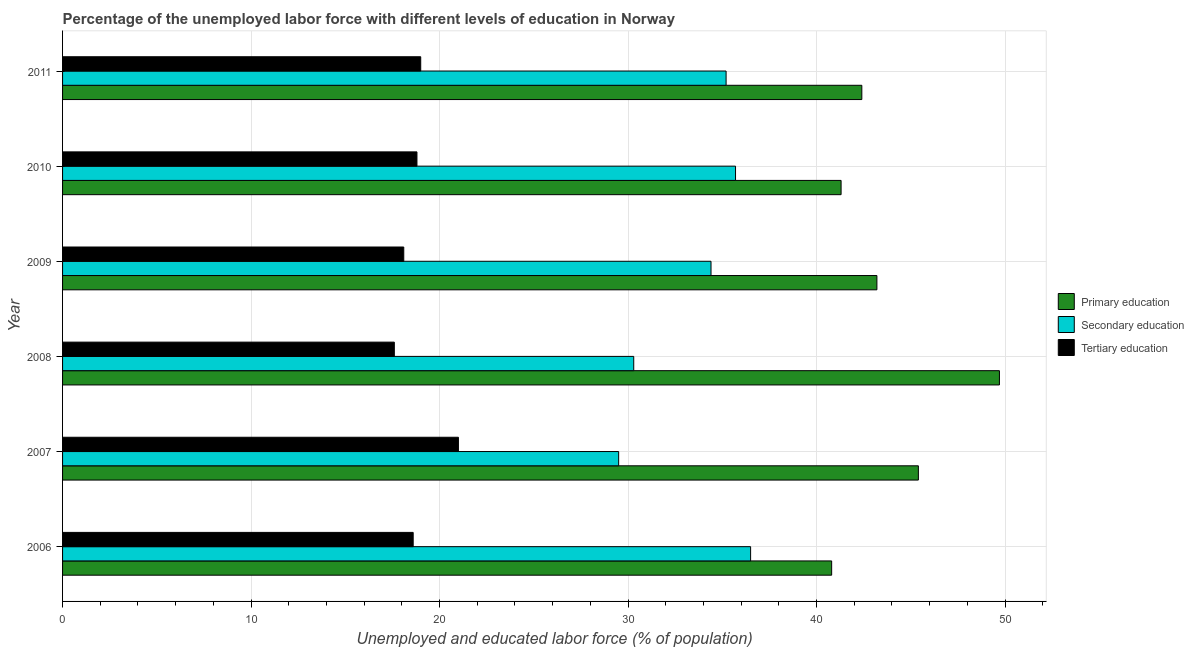How many different coloured bars are there?
Your response must be concise. 3. How many groups of bars are there?
Offer a terse response. 6. How many bars are there on the 6th tick from the top?
Provide a short and direct response. 3. What is the label of the 5th group of bars from the top?
Offer a very short reply. 2007. What is the percentage of labor force who received tertiary education in 2007?
Provide a short and direct response. 21. Across all years, what is the minimum percentage of labor force who received primary education?
Your answer should be very brief. 40.8. In which year was the percentage of labor force who received primary education maximum?
Keep it short and to the point. 2008. In which year was the percentage of labor force who received tertiary education minimum?
Provide a short and direct response. 2008. What is the total percentage of labor force who received tertiary education in the graph?
Your answer should be very brief. 113.1. What is the difference between the percentage of labor force who received tertiary education in 2006 and that in 2011?
Offer a very short reply. -0.4. What is the difference between the percentage of labor force who received primary education in 2006 and the percentage of labor force who received secondary education in 2010?
Offer a very short reply. 5.1. What is the average percentage of labor force who received primary education per year?
Give a very brief answer. 43.8. In how many years, is the percentage of labor force who received tertiary education greater than 46 %?
Your response must be concise. 0. What is the ratio of the percentage of labor force who received tertiary education in 2006 to that in 2008?
Your answer should be very brief. 1.06. Is the difference between the percentage of labor force who received secondary education in 2006 and 2007 greater than the difference between the percentage of labor force who received tertiary education in 2006 and 2007?
Provide a short and direct response. Yes. What is the difference between the highest and the second highest percentage of labor force who received primary education?
Offer a terse response. 4.3. What is the difference between the highest and the lowest percentage of labor force who received secondary education?
Provide a short and direct response. 7. In how many years, is the percentage of labor force who received secondary education greater than the average percentage of labor force who received secondary education taken over all years?
Offer a terse response. 4. What does the 2nd bar from the bottom in 2006 represents?
Keep it short and to the point. Secondary education. How many bars are there?
Your response must be concise. 18. Are all the bars in the graph horizontal?
Provide a short and direct response. Yes. How many years are there in the graph?
Provide a succinct answer. 6. Does the graph contain grids?
Your response must be concise. Yes. How many legend labels are there?
Provide a short and direct response. 3. How are the legend labels stacked?
Keep it short and to the point. Vertical. What is the title of the graph?
Ensure brevity in your answer.  Percentage of the unemployed labor force with different levels of education in Norway. Does "Poland" appear as one of the legend labels in the graph?
Your answer should be very brief. No. What is the label or title of the X-axis?
Provide a short and direct response. Unemployed and educated labor force (% of population). What is the label or title of the Y-axis?
Provide a succinct answer. Year. What is the Unemployed and educated labor force (% of population) of Primary education in 2006?
Offer a terse response. 40.8. What is the Unemployed and educated labor force (% of population) of Secondary education in 2006?
Your answer should be very brief. 36.5. What is the Unemployed and educated labor force (% of population) in Tertiary education in 2006?
Your response must be concise. 18.6. What is the Unemployed and educated labor force (% of population) in Primary education in 2007?
Keep it short and to the point. 45.4. What is the Unemployed and educated labor force (% of population) of Secondary education in 2007?
Make the answer very short. 29.5. What is the Unemployed and educated labor force (% of population) in Tertiary education in 2007?
Ensure brevity in your answer.  21. What is the Unemployed and educated labor force (% of population) of Primary education in 2008?
Provide a succinct answer. 49.7. What is the Unemployed and educated labor force (% of population) in Secondary education in 2008?
Your response must be concise. 30.3. What is the Unemployed and educated labor force (% of population) in Tertiary education in 2008?
Offer a very short reply. 17.6. What is the Unemployed and educated labor force (% of population) in Primary education in 2009?
Your answer should be very brief. 43.2. What is the Unemployed and educated labor force (% of population) in Secondary education in 2009?
Your answer should be compact. 34.4. What is the Unemployed and educated labor force (% of population) of Tertiary education in 2009?
Provide a short and direct response. 18.1. What is the Unemployed and educated labor force (% of population) in Primary education in 2010?
Offer a very short reply. 41.3. What is the Unemployed and educated labor force (% of population) of Secondary education in 2010?
Provide a short and direct response. 35.7. What is the Unemployed and educated labor force (% of population) in Tertiary education in 2010?
Offer a very short reply. 18.8. What is the Unemployed and educated labor force (% of population) of Primary education in 2011?
Keep it short and to the point. 42.4. What is the Unemployed and educated labor force (% of population) in Secondary education in 2011?
Provide a short and direct response. 35.2. Across all years, what is the maximum Unemployed and educated labor force (% of population) of Primary education?
Your answer should be compact. 49.7. Across all years, what is the maximum Unemployed and educated labor force (% of population) in Secondary education?
Your answer should be very brief. 36.5. Across all years, what is the maximum Unemployed and educated labor force (% of population) in Tertiary education?
Your answer should be compact. 21. Across all years, what is the minimum Unemployed and educated labor force (% of population) of Primary education?
Give a very brief answer. 40.8. Across all years, what is the minimum Unemployed and educated labor force (% of population) in Secondary education?
Make the answer very short. 29.5. Across all years, what is the minimum Unemployed and educated labor force (% of population) of Tertiary education?
Offer a terse response. 17.6. What is the total Unemployed and educated labor force (% of population) in Primary education in the graph?
Your response must be concise. 262.8. What is the total Unemployed and educated labor force (% of population) of Secondary education in the graph?
Offer a very short reply. 201.6. What is the total Unemployed and educated labor force (% of population) in Tertiary education in the graph?
Your response must be concise. 113.1. What is the difference between the Unemployed and educated labor force (% of population) in Tertiary education in 2006 and that in 2007?
Provide a succinct answer. -2.4. What is the difference between the Unemployed and educated labor force (% of population) in Primary education in 2006 and that in 2008?
Keep it short and to the point. -8.9. What is the difference between the Unemployed and educated labor force (% of population) in Secondary education in 2006 and that in 2008?
Ensure brevity in your answer.  6.2. What is the difference between the Unemployed and educated labor force (% of population) of Tertiary education in 2006 and that in 2008?
Keep it short and to the point. 1. What is the difference between the Unemployed and educated labor force (% of population) in Secondary education in 2006 and that in 2009?
Your response must be concise. 2.1. What is the difference between the Unemployed and educated labor force (% of population) in Tertiary education in 2006 and that in 2009?
Ensure brevity in your answer.  0.5. What is the difference between the Unemployed and educated labor force (% of population) in Primary education in 2006 and that in 2010?
Your answer should be compact. -0.5. What is the difference between the Unemployed and educated labor force (% of population) in Secondary education in 2006 and that in 2010?
Your answer should be very brief. 0.8. What is the difference between the Unemployed and educated labor force (% of population) of Tertiary education in 2006 and that in 2010?
Your answer should be compact. -0.2. What is the difference between the Unemployed and educated labor force (% of population) of Secondary education in 2006 and that in 2011?
Keep it short and to the point. 1.3. What is the difference between the Unemployed and educated labor force (% of population) in Primary education in 2007 and that in 2008?
Provide a short and direct response. -4.3. What is the difference between the Unemployed and educated labor force (% of population) of Secondary education in 2007 and that in 2008?
Offer a very short reply. -0.8. What is the difference between the Unemployed and educated labor force (% of population) of Tertiary education in 2007 and that in 2008?
Provide a succinct answer. 3.4. What is the difference between the Unemployed and educated labor force (% of population) of Primary education in 2007 and that in 2009?
Your answer should be compact. 2.2. What is the difference between the Unemployed and educated labor force (% of population) of Primary education in 2007 and that in 2010?
Give a very brief answer. 4.1. What is the difference between the Unemployed and educated labor force (% of population) in Tertiary education in 2007 and that in 2010?
Provide a succinct answer. 2.2. What is the difference between the Unemployed and educated labor force (% of population) of Primary education in 2007 and that in 2011?
Keep it short and to the point. 3. What is the difference between the Unemployed and educated labor force (% of population) in Secondary education in 2007 and that in 2011?
Your answer should be compact. -5.7. What is the difference between the Unemployed and educated labor force (% of population) of Primary education in 2008 and that in 2009?
Your answer should be compact. 6.5. What is the difference between the Unemployed and educated labor force (% of population) in Tertiary education in 2008 and that in 2009?
Keep it short and to the point. -0.5. What is the difference between the Unemployed and educated labor force (% of population) in Secondary education in 2008 and that in 2010?
Ensure brevity in your answer.  -5.4. What is the difference between the Unemployed and educated labor force (% of population) in Primary education in 2008 and that in 2011?
Your response must be concise. 7.3. What is the difference between the Unemployed and educated labor force (% of population) of Tertiary education in 2008 and that in 2011?
Keep it short and to the point. -1.4. What is the difference between the Unemployed and educated labor force (% of population) in Secondary education in 2009 and that in 2010?
Your answer should be very brief. -1.3. What is the difference between the Unemployed and educated labor force (% of population) in Tertiary education in 2009 and that in 2010?
Ensure brevity in your answer.  -0.7. What is the difference between the Unemployed and educated labor force (% of population) of Primary education in 2009 and that in 2011?
Make the answer very short. 0.8. What is the difference between the Unemployed and educated labor force (% of population) of Primary education in 2010 and that in 2011?
Ensure brevity in your answer.  -1.1. What is the difference between the Unemployed and educated labor force (% of population) in Primary education in 2006 and the Unemployed and educated labor force (% of population) in Secondary education in 2007?
Your answer should be compact. 11.3. What is the difference between the Unemployed and educated labor force (% of population) in Primary education in 2006 and the Unemployed and educated labor force (% of population) in Tertiary education in 2007?
Offer a terse response. 19.8. What is the difference between the Unemployed and educated labor force (% of population) in Secondary education in 2006 and the Unemployed and educated labor force (% of population) in Tertiary education in 2007?
Offer a terse response. 15.5. What is the difference between the Unemployed and educated labor force (% of population) of Primary education in 2006 and the Unemployed and educated labor force (% of population) of Tertiary education in 2008?
Offer a terse response. 23.2. What is the difference between the Unemployed and educated labor force (% of population) of Secondary education in 2006 and the Unemployed and educated labor force (% of population) of Tertiary education in 2008?
Provide a succinct answer. 18.9. What is the difference between the Unemployed and educated labor force (% of population) of Primary education in 2006 and the Unemployed and educated labor force (% of population) of Secondary education in 2009?
Offer a very short reply. 6.4. What is the difference between the Unemployed and educated labor force (% of population) of Primary education in 2006 and the Unemployed and educated labor force (% of population) of Tertiary education in 2009?
Keep it short and to the point. 22.7. What is the difference between the Unemployed and educated labor force (% of population) in Primary education in 2006 and the Unemployed and educated labor force (% of population) in Secondary education in 2010?
Ensure brevity in your answer.  5.1. What is the difference between the Unemployed and educated labor force (% of population) of Primary education in 2006 and the Unemployed and educated labor force (% of population) of Secondary education in 2011?
Provide a succinct answer. 5.6. What is the difference between the Unemployed and educated labor force (% of population) of Primary education in 2006 and the Unemployed and educated labor force (% of population) of Tertiary education in 2011?
Keep it short and to the point. 21.8. What is the difference between the Unemployed and educated labor force (% of population) in Primary education in 2007 and the Unemployed and educated labor force (% of population) in Secondary education in 2008?
Offer a very short reply. 15.1. What is the difference between the Unemployed and educated labor force (% of population) in Primary education in 2007 and the Unemployed and educated labor force (% of population) in Tertiary education in 2008?
Your answer should be very brief. 27.8. What is the difference between the Unemployed and educated labor force (% of population) of Primary education in 2007 and the Unemployed and educated labor force (% of population) of Secondary education in 2009?
Provide a short and direct response. 11. What is the difference between the Unemployed and educated labor force (% of population) of Primary education in 2007 and the Unemployed and educated labor force (% of population) of Tertiary education in 2009?
Your answer should be compact. 27.3. What is the difference between the Unemployed and educated labor force (% of population) in Primary education in 2007 and the Unemployed and educated labor force (% of population) in Tertiary education in 2010?
Make the answer very short. 26.6. What is the difference between the Unemployed and educated labor force (% of population) in Primary education in 2007 and the Unemployed and educated labor force (% of population) in Tertiary education in 2011?
Provide a succinct answer. 26.4. What is the difference between the Unemployed and educated labor force (% of population) of Secondary education in 2007 and the Unemployed and educated labor force (% of population) of Tertiary education in 2011?
Your answer should be very brief. 10.5. What is the difference between the Unemployed and educated labor force (% of population) in Primary education in 2008 and the Unemployed and educated labor force (% of population) in Secondary education in 2009?
Ensure brevity in your answer.  15.3. What is the difference between the Unemployed and educated labor force (% of population) in Primary education in 2008 and the Unemployed and educated labor force (% of population) in Tertiary education in 2009?
Provide a succinct answer. 31.6. What is the difference between the Unemployed and educated labor force (% of population) of Secondary education in 2008 and the Unemployed and educated labor force (% of population) of Tertiary education in 2009?
Make the answer very short. 12.2. What is the difference between the Unemployed and educated labor force (% of population) of Primary education in 2008 and the Unemployed and educated labor force (% of population) of Tertiary education in 2010?
Keep it short and to the point. 30.9. What is the difference between the Unemployed and educated labor force (% of population) of Primary education in 2008 and the Unemployed and educated labor force (% of population) of Secondary education in 2011?
Your response must be concise. 14.5. What is the difference between the Unemployed and educated labor force (% of population) of Primary education in 2008 and the Unemployed and educated labor force (% of population) of Tertiary education in 2011?
Your answer should be compact. 30.7. What is the difference between the Unemployed and educated labor force (% of population) of Secondary education in 2008 and the Unemployed and educated labor force (% of population) of Tertiary education in 2011?
Offer a very short reply. 11.3. What is the difference between the Unemployed and educated labor force (% of population) of Primary education in 2009 and the Unemployed and educated labor force (% of population) of Secondary education in 2010?
Your response must be concise. 7.5. What is the difference between the Unemployed and educated labor force (% of population) in Primary education in 2009 and the Unemployed and educated labor force (% of population) in Tertiary education in 2010?
Make the answer very short. 24.4. What is the difference between the Unemployed and educated labor force (% of population) in Secondary education in 2009 and the Unemployed and educated labor force (% of population) in Tertiary education in 2010?
Your answer should be compact. 15.6. What is the difference between the Unemployed and educated labor force (% of population) of Primary education in 2009 and the Unemployed and educated labor force (% of population) of Secondary education in 2011?
Provide a succinct answer. 8. What is the difference between the Unemployed and educated labor force (% of population) in Primary education in 2009 and the Unemployed and educated labor force (% of population) in Tertiary education in 2011?
Make the answer very short. 24.2. What is the difference between the Unemployed and educated labor force (% of population) of Primary education in 2010 and the Unemployed and educated labor force (% of population) of Secondary education in 2011?
Provide a succinct answer. 6.1. What is the difference between the Unemployed and educated labor force (% of population) of Primary education in 2010 and the Unemployed and educated labor force (% of population) of Tertiary education in 2011?
Provide a succinct answer. 22.3. What is the average Unemployed and educated labor force (% of population) of Primary education per year?
Keep it short and to the point. 43.8. What is the average Unemployed and educated labor force (% of population) of Secondary education per year?
Your answer should be compact. 33.6. What is the average Unemployed and educated labor force (% of population) in Tertiary education per year?
Offer a very short reply. 18.85. In the year 2006, what is the difference between the Unemployed and educated labor force (% of population) in Primary education and Unemployed and educated labor force (% of population) in Secondary education?
Offer a terse response. 4.3. In the year 2007, what is the difference between the Unemployed and educated labor force (% of population) of Primary education and Unemployed and educated labor force (% of population) of Secondary education?
Make the answer very short. 15.9. In the year 2007, what is the difference between the Unemployed and educated labor force (% of population) of Primary education and Unemployed and educated labor force (% of population) of Tertiary education?
Your response must be concise. 24.4. In the year 2007, what is the difference between the Unemployed and educated labor force (% of population) in Secondary education and Unemployed and educated labor force (% of population) in Tertiary education?
Your answer should be compact. 8.5. In the year 2008, what is the difference between the Unemployed and educated labor force (% of population) of Primary education and Unemployed and educated labor force (% of population) of Tertiary education?
Offer a very short reply. 32.1. In the year 2009, what is the difference between the Unemployed and educated labor force (% of population) of Primary education and Unemployed and educated labor force (% of population) of Secondary education?
Give a very brief answer. 8.8. In the year 2009, what is the difference between the Unemployed and educated labor force (% of population) in Primary education and Unemployed and educated labor force (% of population) in Tertiary education?
Provide a short and direct response. 25.1. In the year 2011, what is the difference between the Unemployed and educated labor force (% of population) in Primary education and Unemployed and educated labor force (% of population) in Secondary education?
Give a very brief answer. 7.2. In the year 2011, what is the difference between the Unemployed and educated labor force (% of population) in Primary education and Unemployed and educated labor force (% of population) in Tertiary education?
Make the answer very short. 23.4. In the year 2011, what is the difference between the Unemployed and educated labor force (% of population) of Secondary education and Unemployed and educated labor force (% of population) of Tertiary education?
Provide a succinct answer. 16.2. What is the ratio of the Unemployed and educated labor force (% of population) of Primary education in 2006 to that in 2007?
Offer a very short reply. 0.9. What is the ratio of the Unemployed and educated labor force (% of population) of Secondary education in 2006 to that in 2007?
Give a very brief answer. 1.24. What is the ratio of the Unemployed and educated labor force (% of population) in Tertiary education in 2006 to that in 2007?
Your response must be concise. 0.89. What is the ratio of the Unemployed and educated labor force (% of population) in Primary education in 2006 to that in 2008?
Offer a very short reply. 0.82. What is the ratio of the Unemployed and educated labor force (% of population) of Secondary education in 2006 to that in 2008?
Offer a terse response. 1.2. What is the ratio of the Unemployed and educated labor force (% of population) in Tertiary education in 2006 to that in 2008?
Provide a succinct answer. 1.06. What is the ratio of the Unemployed and educated labor force (% of population) of Primary education in 2006 to that in 2009?
Provide a succinct answer. 0.94. What is the ratio of the Unemployed and educated labor force (% of population) in Secondary education in 2006 to that in 2009?
Give a very brief answer. 1.06. What is the ratio of the Unemployed and educated labor force (% of population) in Tertiary education in 2006 to that in 2009?
Keep it short and to the point. 1.03. What is the ratio of the Unemployed and educated labor force (% of population) in Primary education in 2006 to that in 2010?
Provide a short and direct response. 0.99. What is the ratio of the Unemployed and educated labor force (% of population) of Secondary education in 2006 to that in 2010?
Make the answer very short. 1.02. What is the ratio of the Unemployed and educated labor force (% of population) in Primary education in 2006 to that in 2011?
Make the answer very short. 0.96. What is the ratio of the Unemployed and educated labor force (% of population) in Secondary education in 2006 to that in 2011?
Your answer should be very brief. 1.04. What is the ratio of the Unemployed and educated labor force (% of population) of Tertiary education in 2006 to that in 2011?
Keep it short and to the point. 0.98. What is the ratio of the Unemployed and educated labor force (% of population) of Primary education in 2007 to that in 2008?
Ensure brevity in your answer.  0.91. What is the ratio of the Unemployed and educated labor force (% of population) of Secondary education in 2007 to that in 2008?
Offer a terse response. 0.97. What is the ratio of the Unemployed and educated labor force (% of population) in Tertiary education in 2007 to that in 2008?
Keep it short and to the point. 1.19. What is the ratio of the Unemployed and educated labor force (% of population) in Primary education in 2007 to that in 2009?
Your response must be concise. 1.05. What is the ratio of the Unemployed and educated labor force (% of population) in Secondary education in 2007 to that in 2009?
Your response must be concise. 0.86. What is the ratio of the Unemployed and educated labor force (% of population) of Tertiary education in 2007 to that in 2009?
Offer a terse response. 1.16. What is the ratio of the Unemployed and educated labor force (% of population) of Primary education in 2007 to that in 2010?
Offer a very short reply. 1.1. What is the ratio of the Unemployed and educated labor force (% of population) in Secondary education in 2007 to that in 2010?
Make the answer very short. 0.83. What is the ratio of the Unemployed and educated labor force (% of population) in Tertiary education in 2007 to that in 2010?
Give a very brief answer. 1.12. What is the ratio of the Unemployed and educated labor force (% of population) in Primary education in 2007 to that in 2011?
Provide a short and direct response. 1.07. What is the ratio of the Unemployed and educated labor force (% of population) of Secondary education in 2007 to that in 2011?
Offer a terse response. 0.84. What is the ratio of the Unemployed and educated labor force (% of population) in Tertiary education in 2007 to that in 2011?
Provide a short and direct response. 1.11. What is the ratio of the Unemployed and educated labor force (% of population) of Primary education in 2008 to that in 2009?
Your answer should be very brief. 1.15. What is the ratio of the Unemployed and educated labor force (% of population) in Secondary education in 2008 to that in 2009?
Your response must be concise. 0.88. What is the ratio of the Unemployed and educated labor force (% of population) in Tertiary education in 2008 to that in 2009?
Provide a short and direct response. 0.97. What is the ratio of the Unemployed and educated labor force (% of population) of Primary education in 2008 to that in 2010?
Ensure brevity in your answer.  1.2. What is the ratio of the Unemployed and educated labor force (% of population) of Secondary education in 2008 to that in 2010?
Make the answer very short. 0.85. What is the ratio of the Unemployed and educated labor force (% of population) of Tertiary education in 2008 to that in 2010?
Your answer should be compact. 0.94. What is the ratio of the Unemployed and educated labor force (% of population) of Primary education in 2008 to that in 2011?
Your answer should be compact. 1.17. What is the ratio of the Unemployed and educated labor force (% of population) in Secondary education in 2008 to that in 2011?
Your response must be concise. 0.86. What is the ratio of the Unemployed and educated labor force (% of population) of Tertiary education in 2008 to that in 2011?
Make the answer very short. 0.93. What is the ratio of the Unemployed and educated labor force (% of population) in Primary education in 2009 to that in 2010?
Provide a succinct answer. 1.05. What is the ratio of the Unemployed and educated labor force (% of population) of Secondary education in 2009 to that in 2010?
Make the answer very short. 0.96. What is the ratio of the Unemployed and educated labor force (% of population) of Tertiary education in 2009 to that in 2010?
Your response must be concise. 0.96. What is the ratio of the Unemployed and educated labor force (% of population) in Primary education in 2009 to that in 2011?
Offer a very short reply. 1.02. What is the ratio of the Unemployed and educated labor force (% of population) in Secondary education in 2009 to that in 2011?
Your response must be concise. 0.98. What is the ratio of the Unemployed and educated labor force (% of population) of Tertiary education in 2009 to that in 2011?
Your answer should be compact. 0.95. What is the ratio of the Unemployed and educated labor force (% of population) in Primary education in 2010 to that in 2011?
Provide a succinct answer. 0.97. What is the ratio of the Unemployed and educated labor force (% of population) in Secondary education in 2010 to that in 2011?
Keep it short and to the point. 1.01. What is the difference between the highest and the second highest Unemployed and educated labor force (% of population) of Tertiary education?
Give a very brief answer. 2. What is the difference between the highest and the lowest Unemployed and educated labor force (% of population) in Primary education?
Make the answer very short. 8.9. What is the difference between the highest and the lowest Unemployed and educated labor force (% of population) of Tertiary education?
Keep it short and to the point. 3.4. 